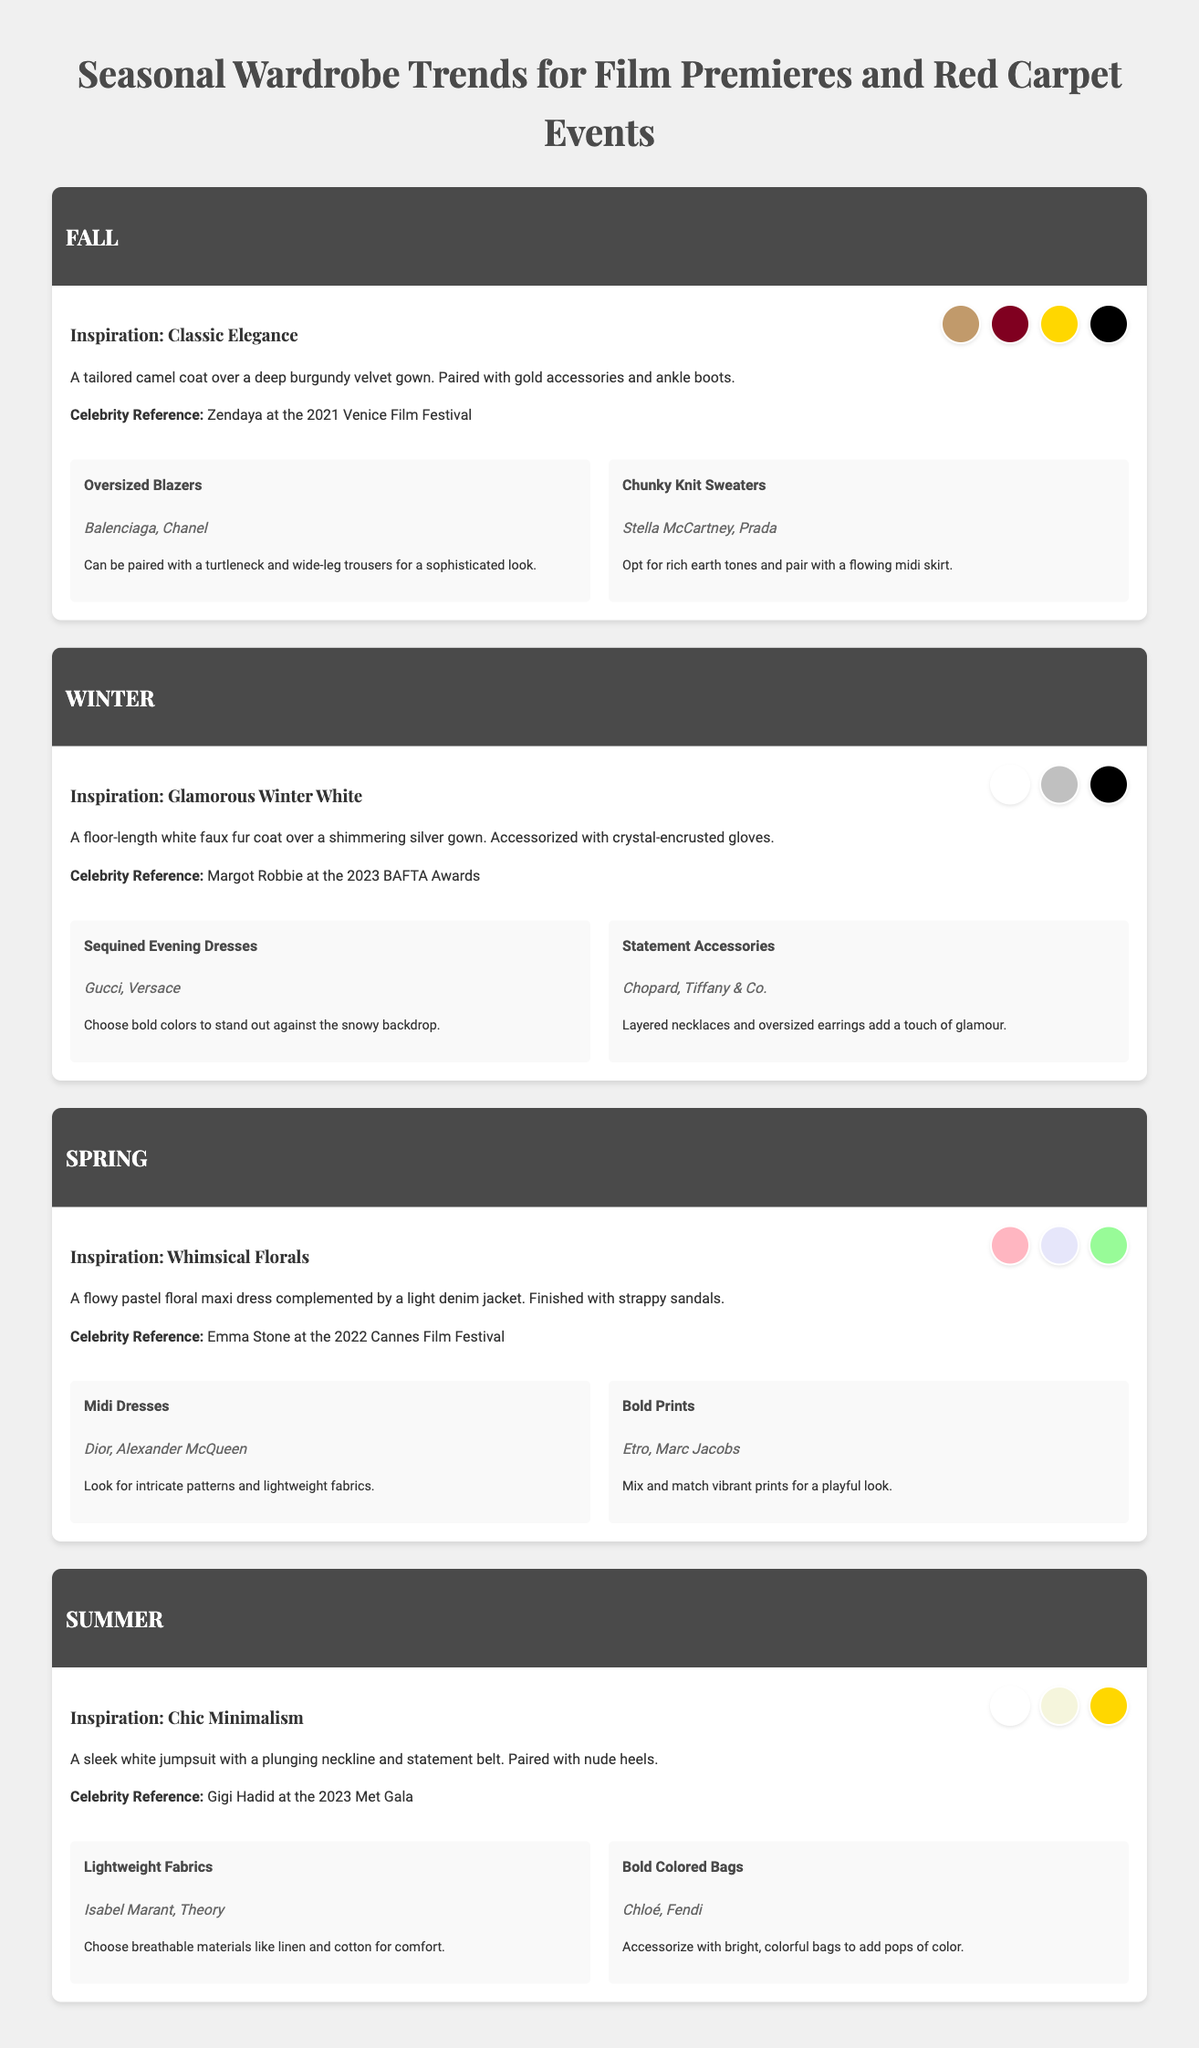What is the color palette for Fall? The Fall color palette includes camel, burgundy, gold, and black, represented by swatches in the document.
Answer: camel, burgundy, gold, black Who is a celebrity reference for Winter? The document mentions Margot Robbie as a celebrity reference for the Winter inspiration.
Answer: Margot Robbie What type of outfit is inspired by Spring? The Spring inspiration suggests a flowy pastel floral maxi dress complemented by a light denim jacket.
Answer: flowy pastel floral maxi dress Which brands are associated with oversized blazers? According to the document, Balenciaga and Chanel are the brands associated with oversized blazers.
Answer: Balenciaga, Chanel What is the main inspiration theme for Summer? The Summer inspiration theme is described as Chic Minimalism.
Answer: Chic Minimalism What kind of accessories are encouraged for Winter? The document highlights statement accessories such as layered necklaces and oversized earrings for Winter.
Answer: statement accessories In which season would you find chunky knit sweaters? Chunky knit sweaters are trending in the Fall season.
Answer: Fall What is the color of the jumpsuit in Summer inspiration? The jumpsuit in the Summer inspiration is described as sleek white.
Answer: sleek white 